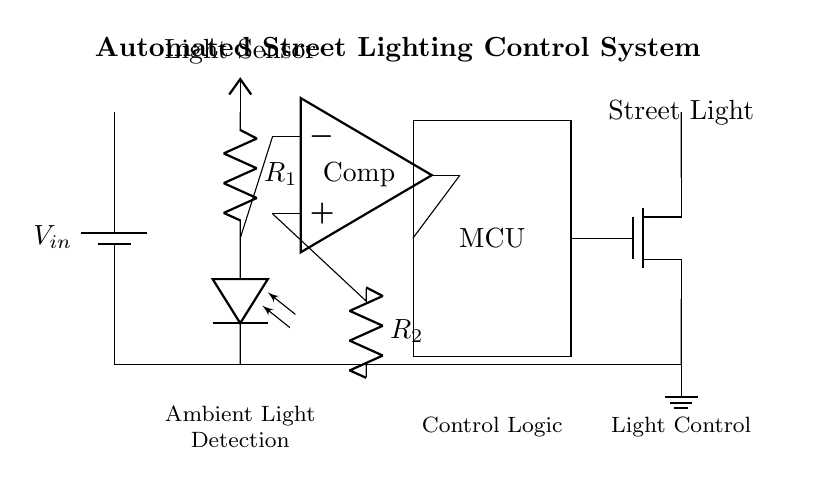What type of sensor is used in this circuit? The circuit uses a light sensor, specifically a photodiode, to detect ambient light levels.
Answer: Light sensor What component controls the street light? The microcontroller receives input from the comparator and sends a signal to the MOSFET to turn the street light on or off.
Answer: Microcontroller How does the circuit determine when to turn the street light on? The light sensor monitors the ambient light; when it falls below a certain threshold, the comparator outputs a signal to activate the microcontroller.
Answer: Sensor threshold Which component acts as a switch for the street light? The MOSFET functions as a switch to control the power to the street light based on the microcontroller's signal.
Answer: MOSFET What is the purpose of the resistor noted as R2? R2 helps to set the gain and reference voltage for the comparator, influencing when the street light will be activated according to ambient light conditions.
Answer: Gain adjustment What happens when the light sensor detects low ambient light levels? The comparator outputs a high signal which is processed by the microcontroller, triggering the MOSFET to turn on the street light.
Answer: Light turns on Which component provides power to the entire circuit? The battery supplies power to all components, ensuring the circuit operates correctly.
Answer: Battery 